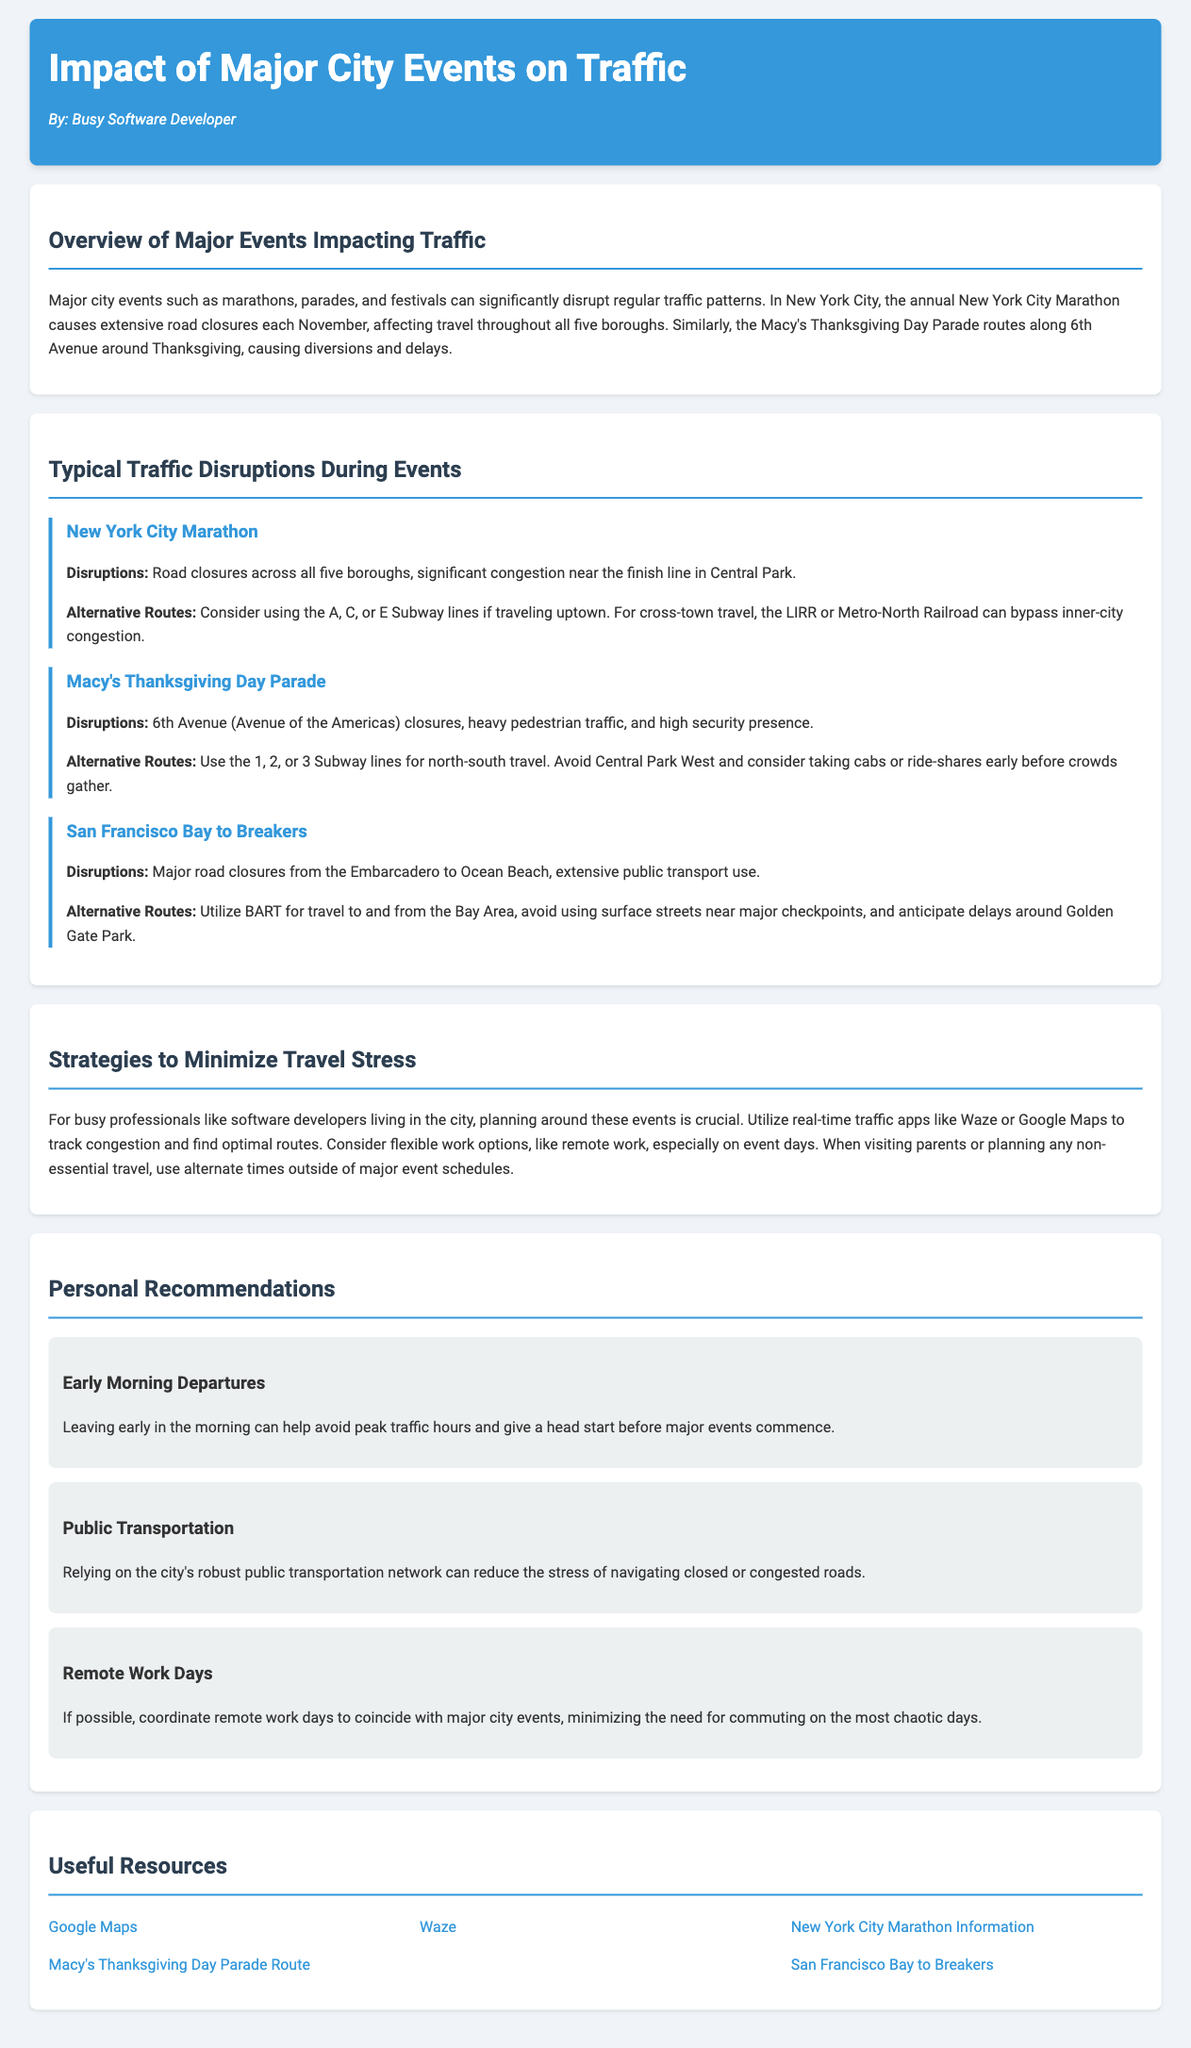What is the title of the report? The title is found in the header section of the document.
Answer: Impact of Major City Events on Traffic Who is the author of the report? The author's name is mentioned below the title in the header section.
Answer: Busy Software Developer What major event causes extensive road closures in November? The event is specifically discussed in the section about disruptions.
Answer: New York City Marathon What is a suggested alternative route for cross-town travel during the New York City Marathon? This information is provided under the event details for the New York City Marathon.
Answer: LIRR or Metro-North Railroad Which subway lines should be used for north-south travel during the Macy's Thanksgiving Day Parade? The answer is located in the disruptions section for the Macy’s Thanksgiving Day Parade.
Answer: 1, 2, or 3 Subway lines What is one strategy to minimize travel stress suggested in the report? The report lists several strategies in the section dedicated to minimizing travel stress.
Answer: Early Morning Departures What impact does the San Francisco Bay to Breakers event have on public transportation? The event details discuss the extent of public transport use during the event.
Answer: Extensive public transport use Which tool can be used to track congestion and find optimal routes? This information is mentioned in the strategies section of the report.
Answer: Google Maps What is a consequence of the Macy's Thanksgiving Day Parade? The section detailing the event describes its consequences on traffic.
Answer: Heavy pedestrian traffic 